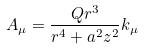<formula> <loc_0><loc_0><loc_500><loc_500>A _ { \mu } = \frac { Q r ^ { 3 } } { r ^ { 4 } + a ^ { 2 } z ^ { 2 } } k _ { \mu }</formula> 